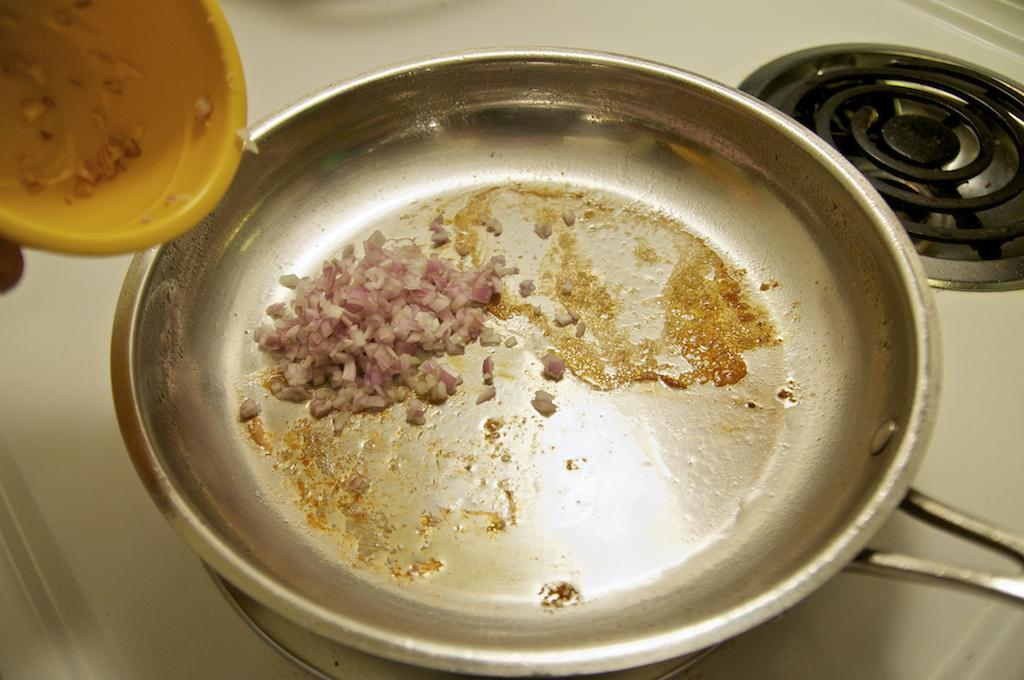What is on the stove in the image? There is a pan on the stove in the image. Where is the pan located in the image? The pan is in the middle of the image. What other container is visible in the image? There is a plastic bowl in the image. Where is the plastic bowl located in the image? The plastic bowl is in the top left-hand side of the image. How many mothers are present in the image? There is no mother present in the image. Can you hear the sound of people laughing in the image? There is no sound in the image, so it is not possible to hear people laughing. 